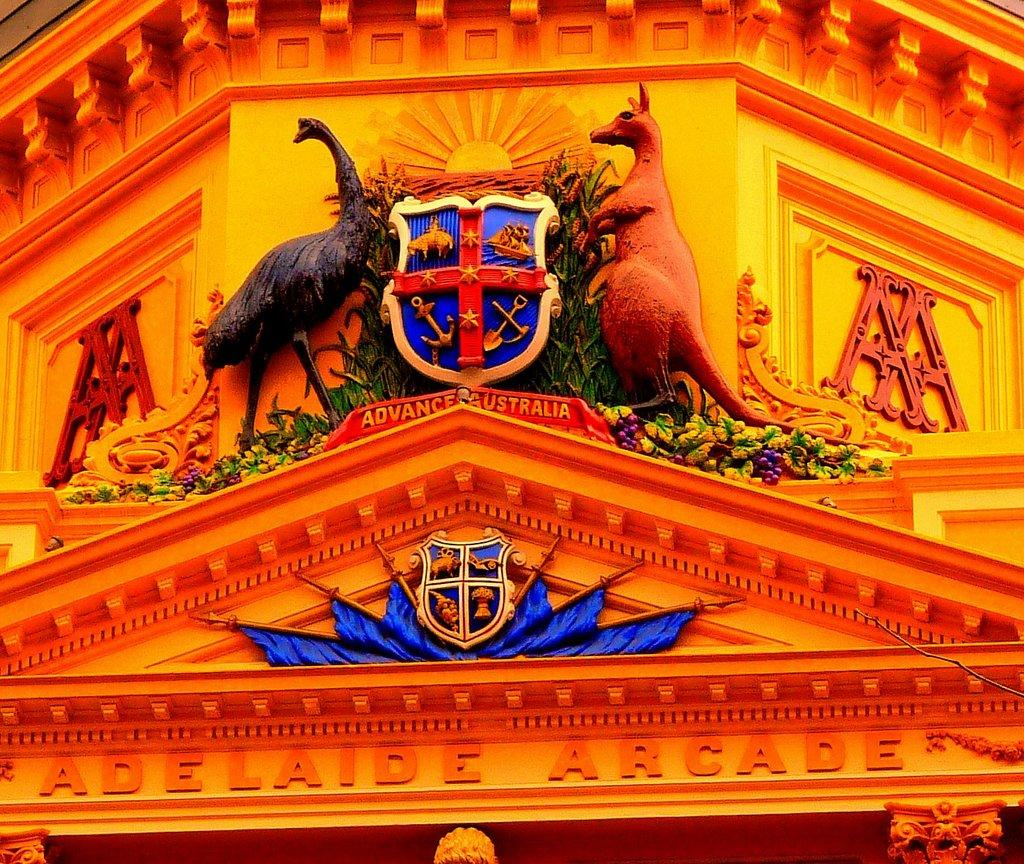What type of structure is visible in the image? There is a building in the image. What can be seen on the building besides its structure? There is text and statues on the building. Are there any other decorative elements on the building? Yes, there are shields on the building. What type of bone is visible on the building in the image? There is no bone present on the building in the image. Can you tell me which actor is standing next to the building in the image? There are no actors present in the image; it only features the building and its decorative elements. 